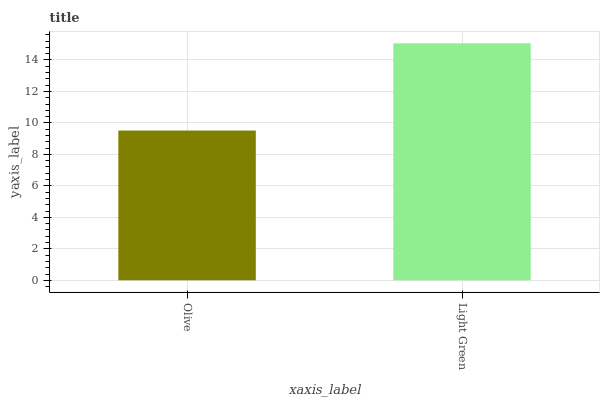Is Olive the minimum?
Answer yes or no. Yes. Is Light Green the maximum?
Answer yes or no. Yes. Is Light Green the minimum?
Answer yes or no. No. Is Light Green greater than Olive?
Answer yes or no. Yes. Is Olive less than Light Green?
Answer yes or no. Yes. Is Olive greater than Light Green?
Answer yes or no. No. Is Light Green less than Olive?
Answer yes or no. No. Is Light Green the high median?
Answer yes or no. Yes. Is Olive the low median?
Answer yes or no. Yes. Is Olive the high median?
Answer yes or no. No. Is Light Green the low median?
Answer yes or no. No. 